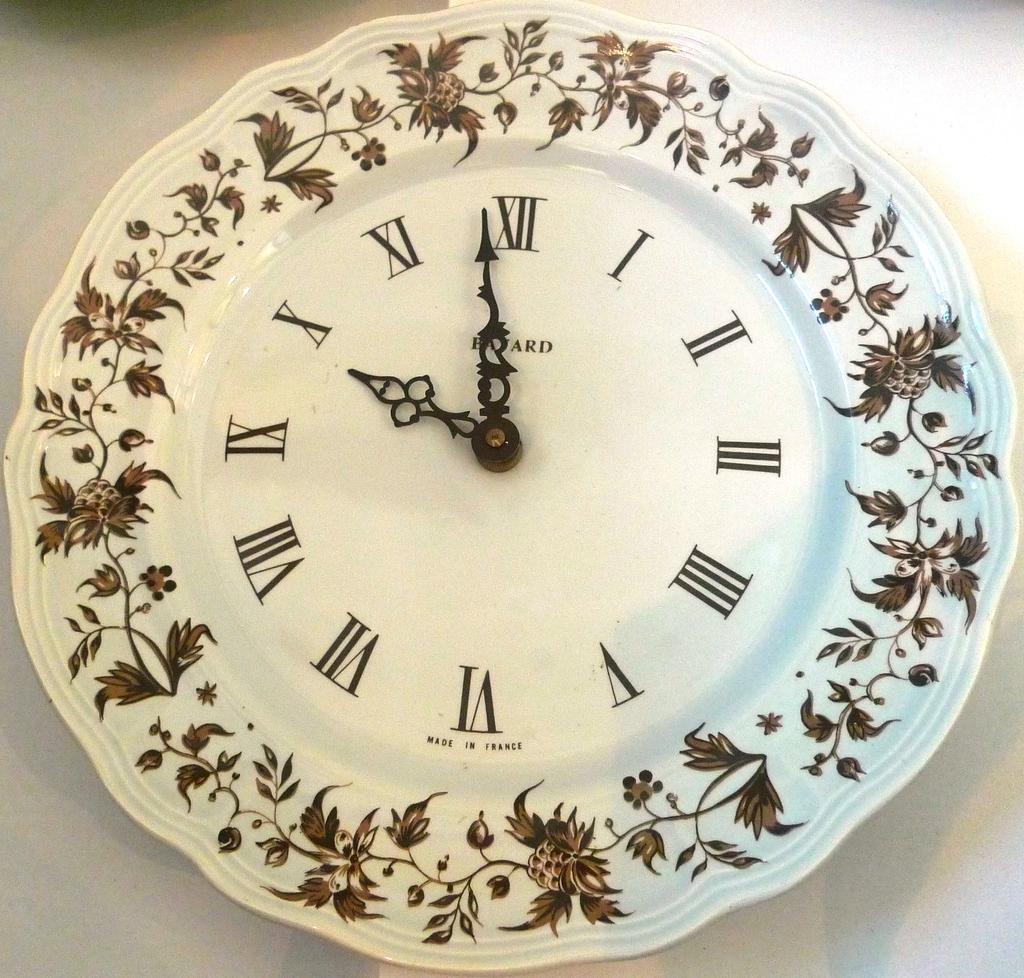What time does the clock display?
Provide a short and direct response. 9:58. 